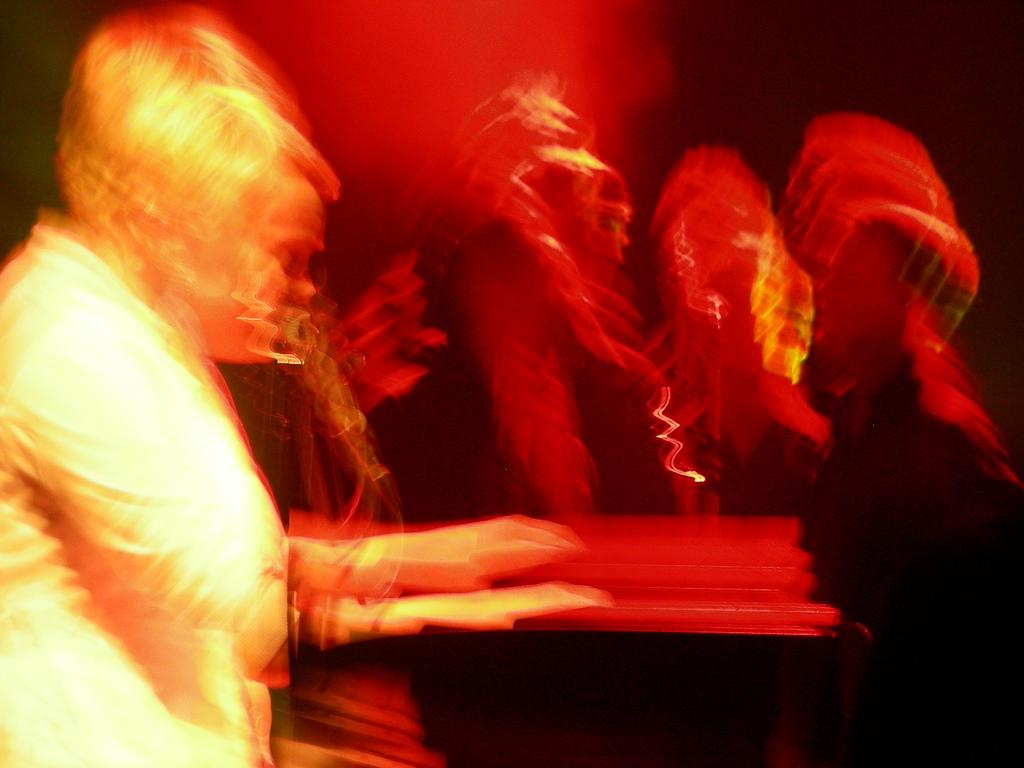How many individuals are present in the image? There is a group of people in the image. What type of coat is the animal wearing in the image? There is no animal present in the image, nor is there any mention of a coat. 